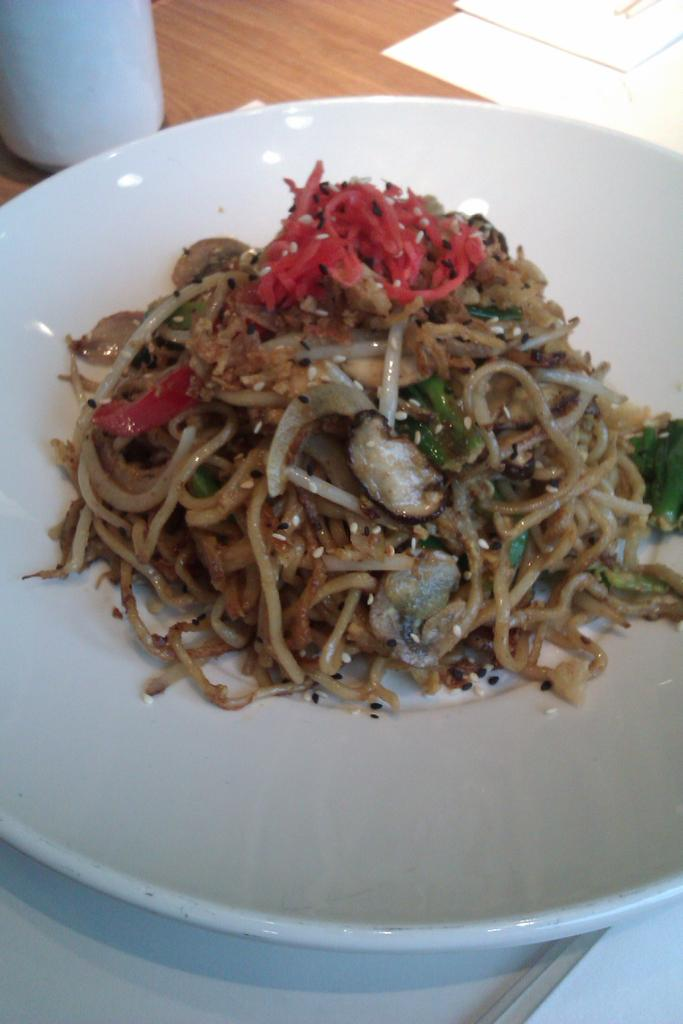What is located in the center of the image? There is a table in the center of the image. What can be found on the table? Papers and a white color object are present on the table. What else is on the table? There is a plate on the table. What is in the plate? There is a food item in the plate. Who is the property expert in the image? There is no property expert present in the image. Can you tell me how many zippers are visible in the image? There are no zippers present in the image. 